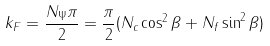Convert formula to latex. <formula><loc_0><loc_0><loc_500><loc_500>k _ { F } = \frac { N _ { \Psi } \pi } { 2 } = \frac { \pi } { 2 } ( N _ { c } \cos ^ { 2 } \beta + N _ { f } \sin ^ { 2 } \beta )</formula> 